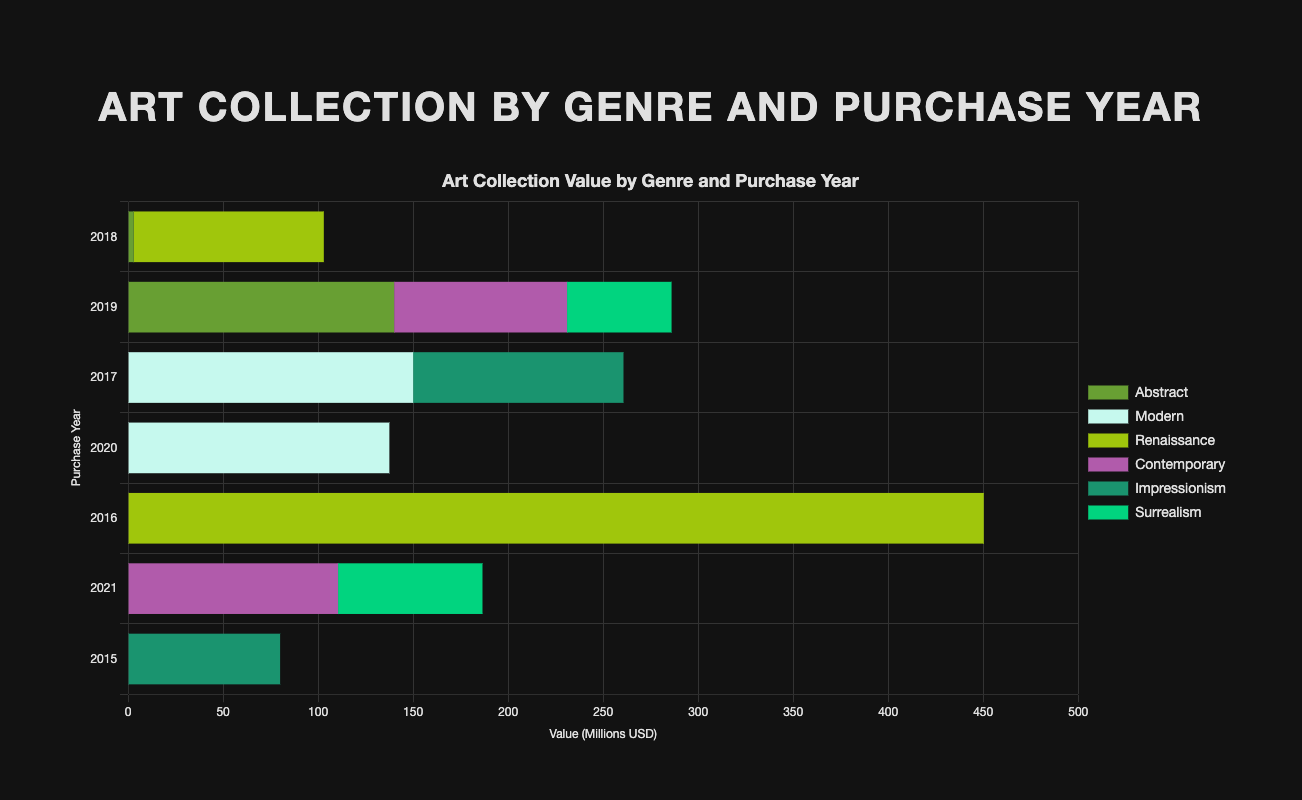What is the total value of Renaissance art purchased in 2016? The chart shows the value of "Salvator Mundi" purchased in 2016 under the Renaissance genre. The value of this artwork is $450,300,000.
Answer: $450,300,000 Which genre had the highest total value of art purchased between 2015 and 2021? Sum the values of all artworks in each genre and compare the sums. Renaissance has the highest total value: "Salvator Mundi" ($450,300,000) in 2016 and "Portrait of a Young Man" ($100,000,000) in 2018, totaling to $550,300,000.
Answer: Renaissance Which genre had the lowest individual artwork value, and what was that value? Examine the value of each artwork and identify the lowest value: "Composition VIII" in the Abstract genre purchased in 2018 has the lowest value of $3,000,000.
Answer: Abstract, $3,000,000 How does the total value of Abstract art compare to the total value of Contemporary art purchased in 2019? Sum the values of Abstract art in 2019 and Contemporary art in 2019. Abstract in 2019 ("No. 5, 1948") is $140,000,000, and Contemporary in 2019 ("Rabbit") is $91,000,000. Abstract art value ($140,000,000) is higher than Contemporary art value ($91,000,000).
Answer: Abstract is higher What is the total value of all artworks purchased in 2019? Add the values of all artworks purchased in 2019: "No. 5, 1948" ($140,000,000), "Rabbit" ($91,000,000), "The Persistence of Memory" ($55,000,000). The total is $140,000,000 + $91,000,000 + $55,000,000 = $286,000,000.
Answer: $286,000,000 Which year had the highest overall purchase value of art, and what was that total? Sum the values of all artworks purchased each year. The year with the highest overall value is 2021 with "Untitled" ($110,500,000) and "The Elephants" ($76,000,000). Total for 2021 is $110,500,000 + $76,000,000 = $186,500,000.
Answer: 2021, $186,500,000 Which genre had more consistent purchase values over the years and what are those values? Compare the purchase values within genres by assessing the consistency of the values across years. Renaissance values are $450,300,000 in 2016 and $100,000,000 in 2018, while Impressionism values are $80,000,000 in 2015 and $110,700,000 in 2017. Impressionism shows more consistency with less variance ($80,000,000 and $110,700,000).
Answer: Impressionism, $80,000,000 and $110,700,000 What is the average value per genre for Modern art? The Modern genre includes two artworks: "Les Demoiselles d'Avignon" ($150,000,000) in 2017 and "Woman III" ($137,500,000) in 2020. The average value is calculated by adding both values and dividing by 2: ($150,000,000 + $137,500,000) / 2 = $143,750,000.
Answer: $143,750,000 Which artwork has the highest value, and who is the artist? Look at the individual values of each artwork. "Salvator Mundi" by Leonardo da Vinci has the highest value at $450,300,000.
Answer: Salvator Mundi, Leonardo da Vinci 